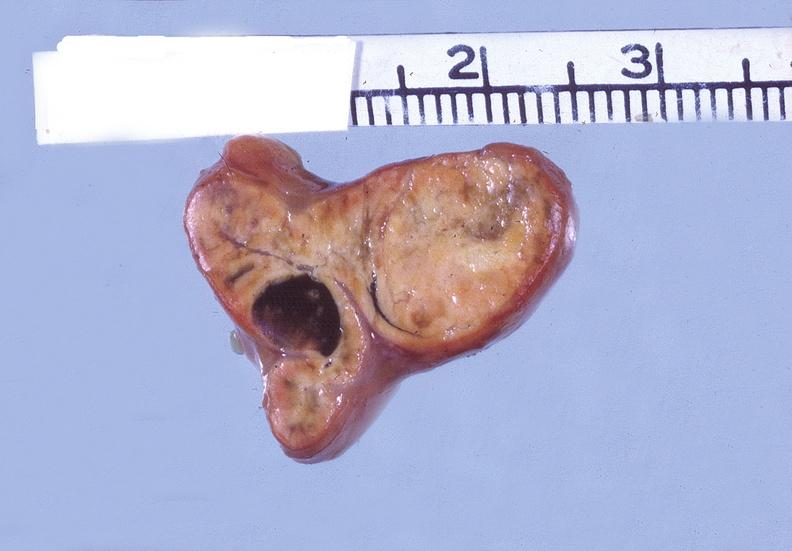what does this image show?
Answer the question using a single word or phrase. Adrenal 